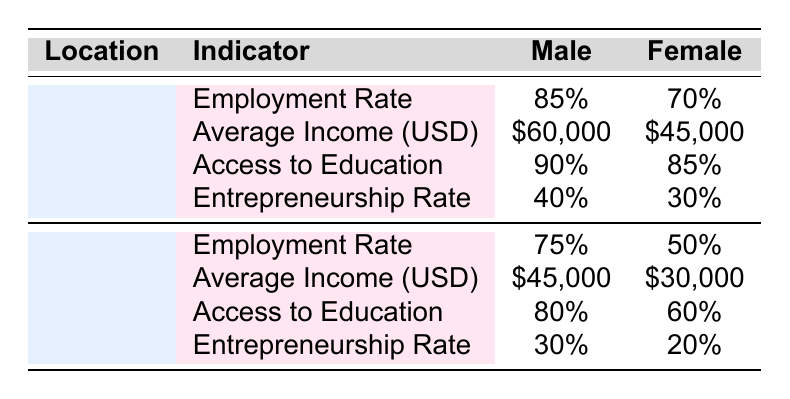What is the employment rate for females in urban areas? The table shows that the employment rate for females in urban areas is 70%.
Answer: 70% What is the average income for males in rural areas? The table indicates that the average income for males in rural areas is $45,000.
Answer: $45,000 Is the entrepreneurship rate higher for males in urban areas compared to males in rural areas? The entrepreneurship rate for males in urban areas is 40%, while in rural areas it is 30%, so yes, it is higher in urban areas.
Answer: Yes What is the difference in access to education between males and females in urban areas? In urban areas, access to education for males is 90% and for females is 85%. The difference is 90% - 85% = 5%.
Answer: 5% Which location has a higher average income for females? The average income for females in urban areas is $45,000, and in rural areas, it is $30,000. Since $45,000 is greater than $30,000, urban areas have a higher average income for females.
Answer: Urban What is the ratio of employment rates for males to females in rural areas? The employment rate for males in rural areas is 75%, and for females, it is 50%. The ratio is 75:50, which simplifies to 1.5:1.
Answer: 1.5:1 What is the total average income for males and females in urban areas combined? The average income for males in urban areas is $60,000 and for females is $45,000. Combining these, the total is $60,000 + $45,000 = $105,000.
Answer: $105,000 Is the access to education for females in rural areas greater than that for males in urban areas? The access to education for females in rural areas is 60%, while for males in urban areas, it is 90%. Since 60% is less than 90%, the statement is false.
Answer: No What is the average access to education percentage for both genders in rural areas? The access to education is 80% for males and 60% for females in rural areas. The average is (80% + 60%) / 2 = 70%.
Answer: 70% 